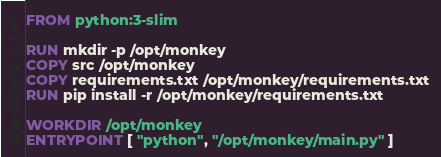<code> <loc_0><loc_0><loc_500><loc_500><_Dockerfile_>FROM python:3-slim

RUN mkdir -p /opt/monkey
COPY src /opt/monkey
COPY requirements.txt /opt/monkey/requirements.txt
RUN pip install -r /opt/monkey/requirements.txt

WORKDIR /opt/monkey
ENTRYPOINT [ "python", "/opt/monkey/main.py" ]
</code> 